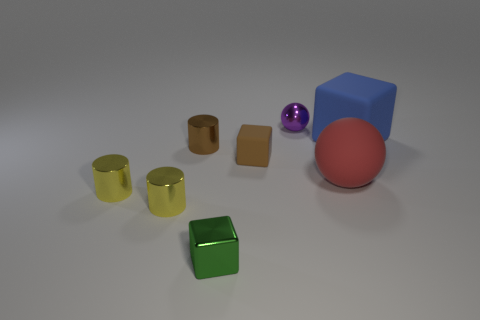How many tiny objects are yellow metal objects or rubber balls?
Offer a terse response. 2. What material is the big blue thing?
Your answer should be very brief. Rubber. What number of other objects are there of the same shape as the green thing?
Offer a very short reply. 2. How big is the purple thing?
Keep it short and to the point. Small. What is the size of the object that is on the left side of the small green metallic object and behind the red rubber object?
Provide a short and direct response. Small. The brown shiny thing that is on the left side of the red sphere has what shape?
Your response must be concise. Cylinder. Do the red sphere and the brown block left of the small shiny sphere have the same material?
Your answer should be very brief. Yes. Does the tiny green object have the same shape as the purple shiny thing?
Provide a short and direct response. No. What is the material of the purple thing that is the same shape as the large red matte object?
Provide a succinct answer. Metal. The block that is behind the shiny cube and on the left side of the big blue rubber object is what color?
Your answer should be compact. Brown. 